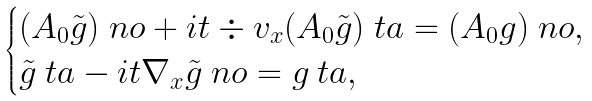Convert formula to latex. <formula><loc_0><loc_0><loc_500><loc_500>\begin{cases} ( A _ { 0 } \tilde { g } ) _ { \ } n o + i t \div v _ { x } ( A _ { 0 } \tilde { g } ) _ { \ } t a = ( A _ { 0 } g ) _ { \ } n o , \\ \tilde { g } _ { \ } t a - i t \nabla _ { x } \tilde { g } _ { \ } n o = g _ { \ } t a , \end{cases}</formula> 